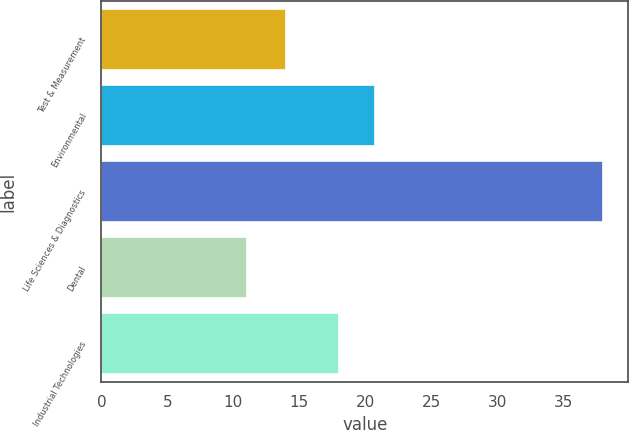<chart> <loc_0><loc_0><loc_500><loc_500><bar_chart><fcel>Test & Measurement<fcel>Environmental<fcel>Life Sciences & Diagnostics<fcel>Dental<fcel>Industrial Technologies<nl><fcel>14<fcel>20.7<fcel>38<fcel>11<fcel>18<nl></chart> 